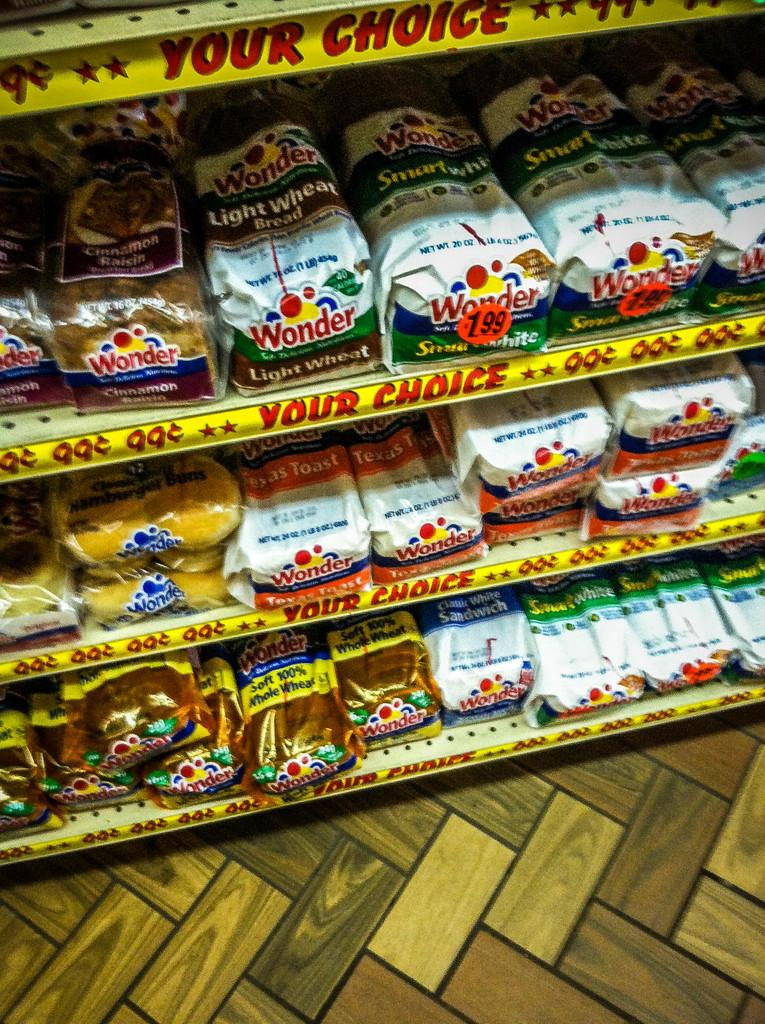<image>
Describe the image concisely. A bread shelf in a store with a sign that says "YOUR CHOICE" and a price of 99 cents. 